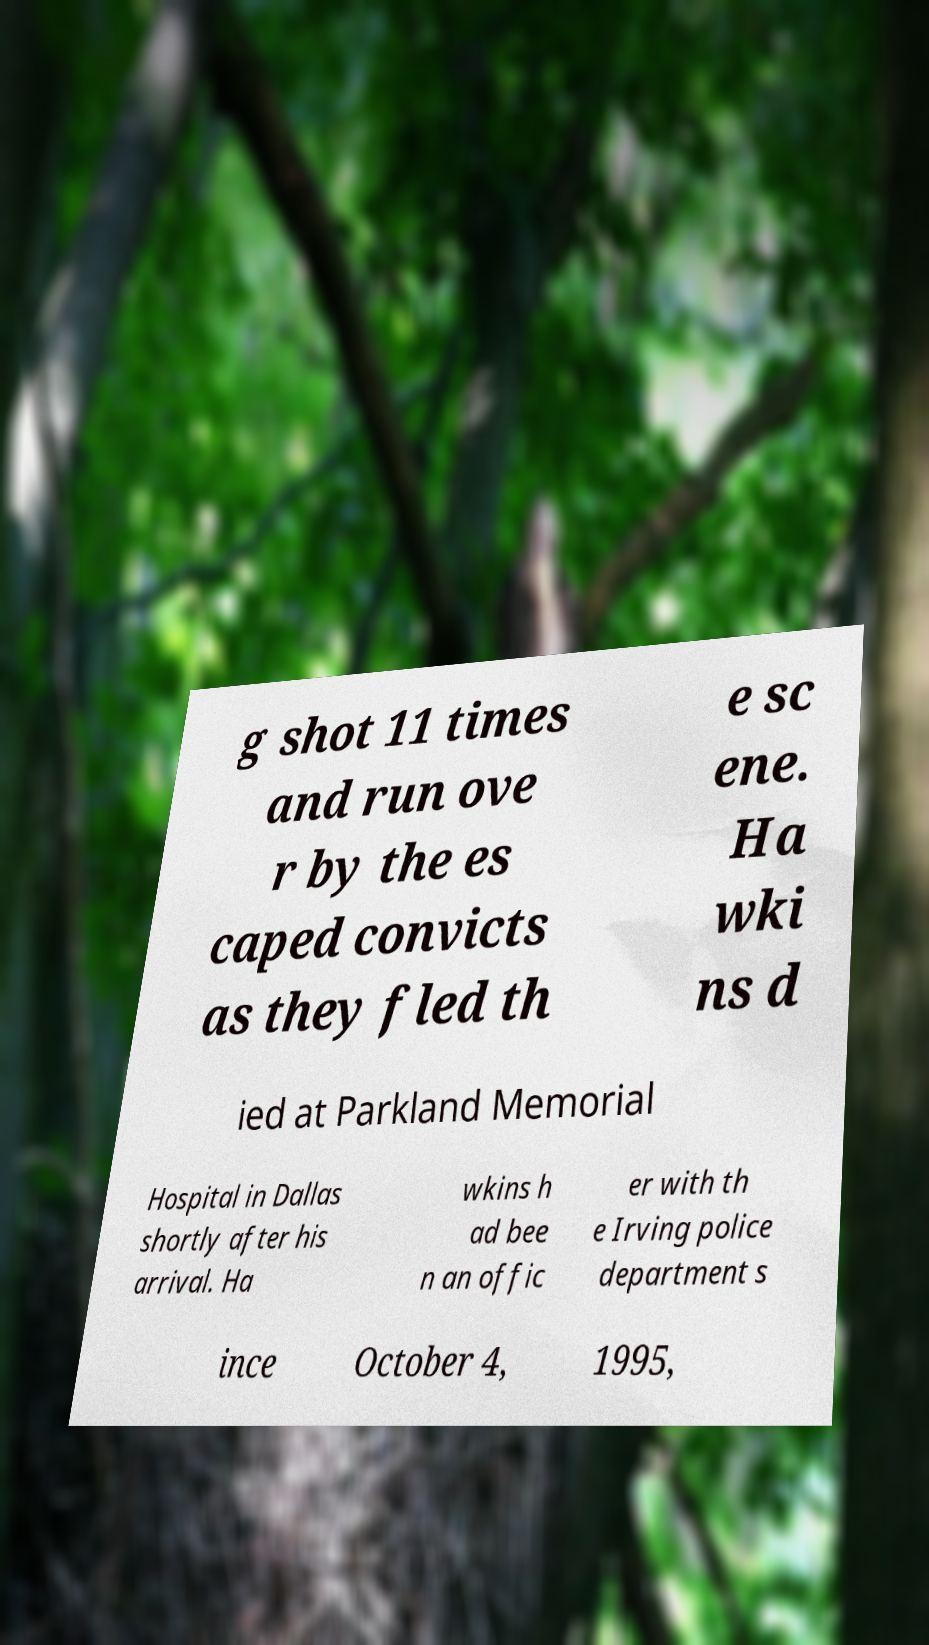Could you assist in decoding the text presented in this image and type it out clearly? g shot 11 times and run ove r by the es caped convicts as they fled th e sc ene. Ha wki ns d ied at Parkland Memorial Hospital in Dallas shortly after his arrival. Ha wkins h ad bee n an offic er with th e Irving police department s ince October 4, 1995, 